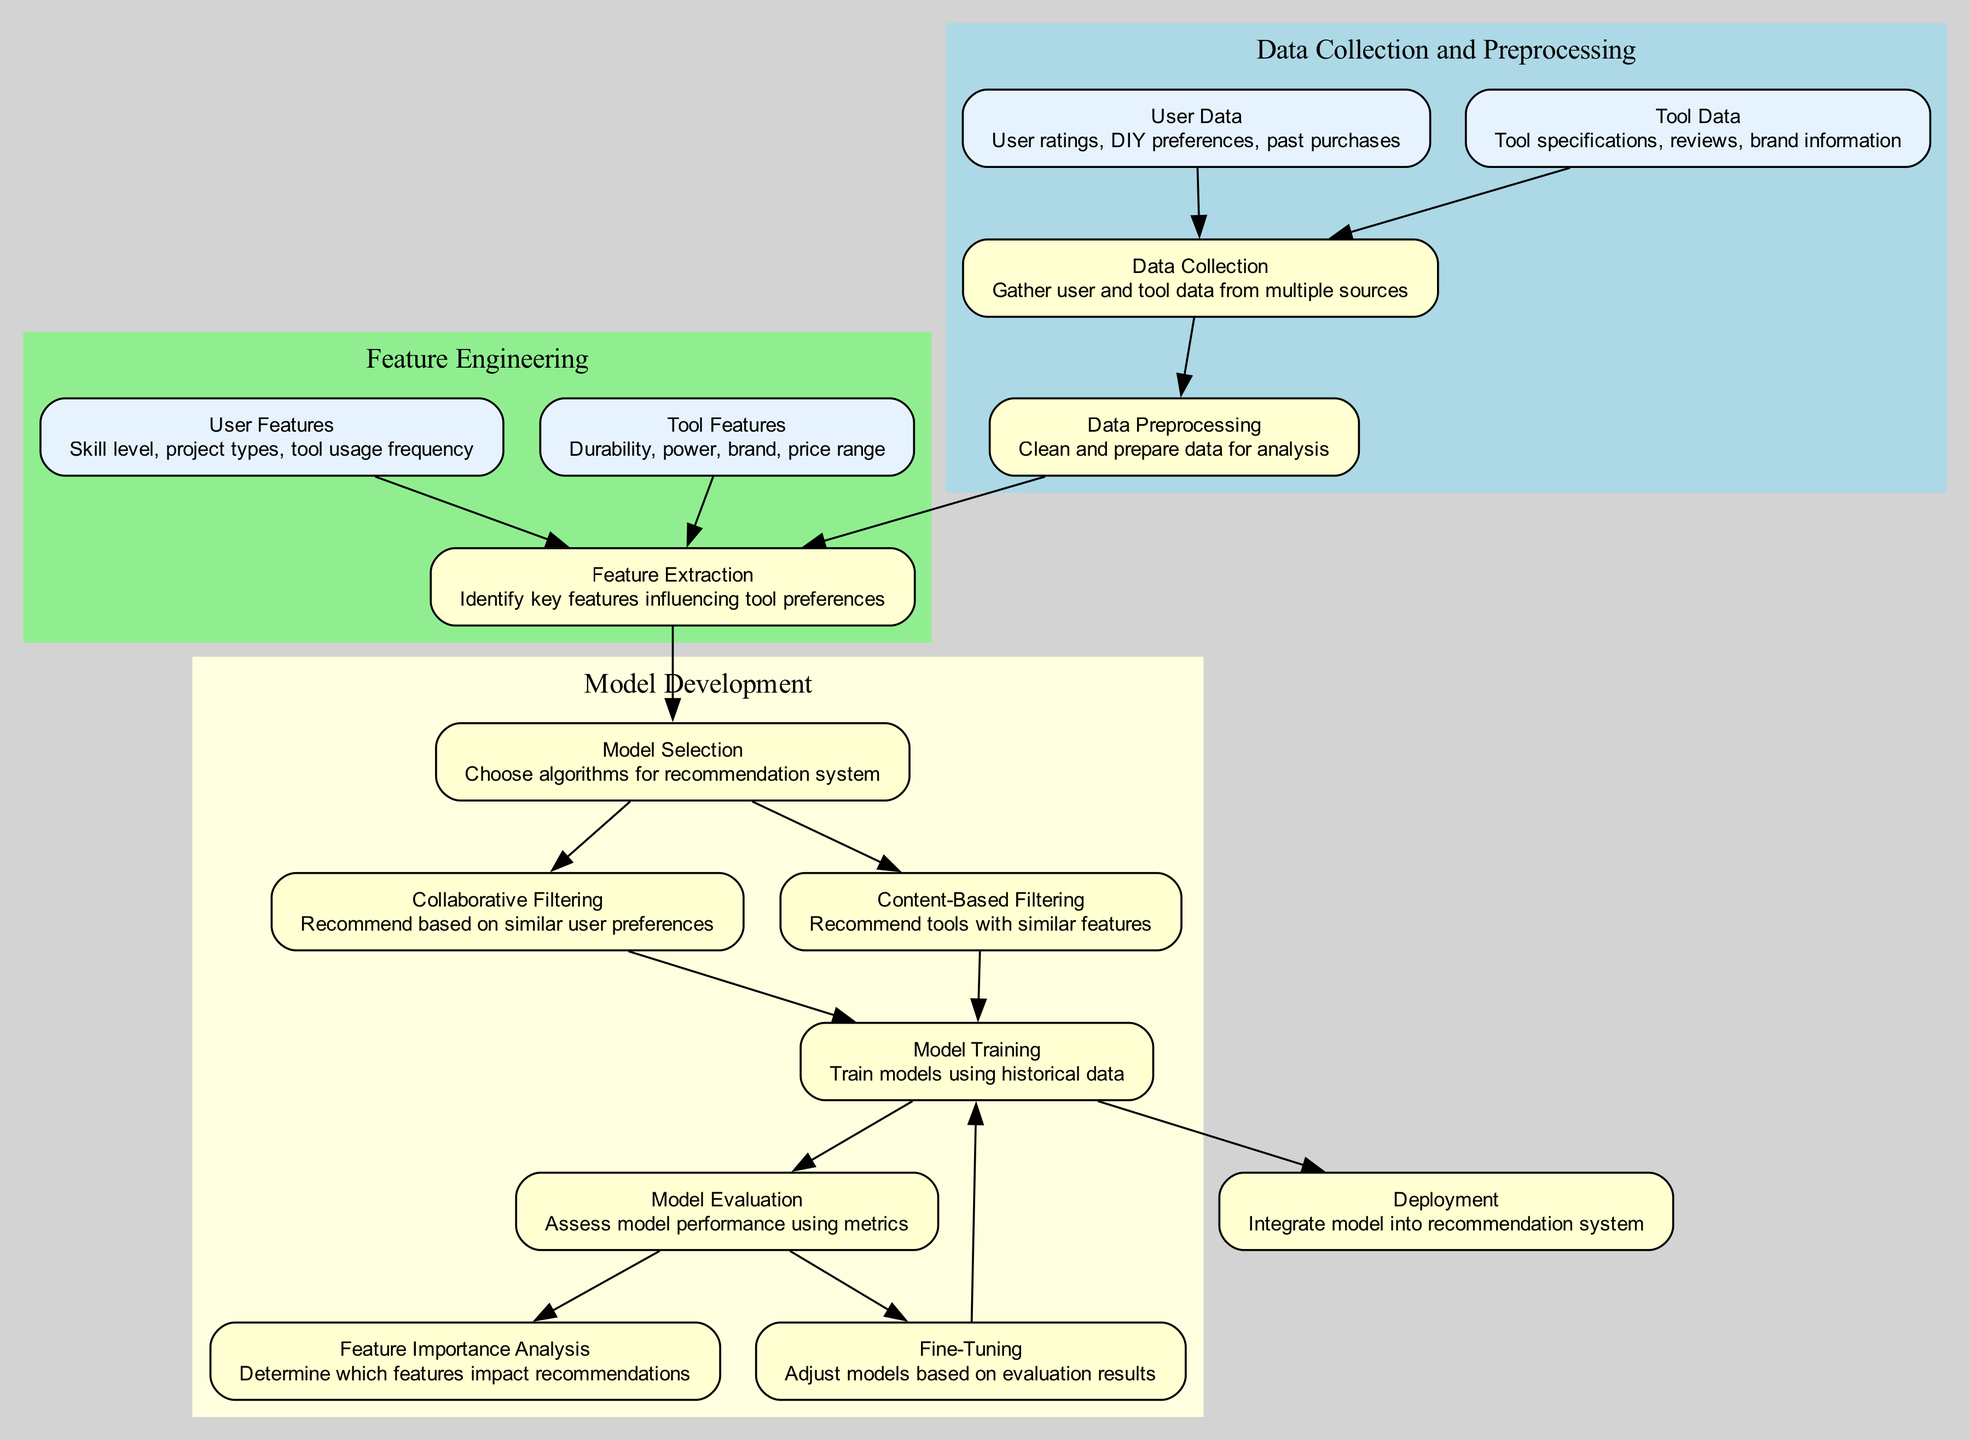What is the first step in the recommendation system process? The first step is 'Data Collection', as indicated by the node labeled '1'. This node is the starting point of the flow in the diagram, making it clear that gathering user and tool data is the initial action.
Answer: Data Collection How many nodes are present in the diagram? By counting each unique labeled node in the diagram, we can see that there are a total of 15 nodes. Each node represents a step or component in the recommendation system process.
Answer: 15 What two types of filtering are used in the model selection? The two types of filtering are 'Collaborative Filtering' and 'Content-Based Filtering'. These nodes are represented under the same category in the diagram, showcasing the methods of recommendation employed.
Answer: Collaborative Filtering, Content-Based Filtering Which feature influences tool preferences related to user skills? The feature that influences tool preferences related to user skills is 'Skill level', which falls under the 'User Features' node. This indicates a direct relationship between user skills and their tool preferences.
Answer: Skill level What is the last step before deployment in the process? The last step before deployment is 'Model Training', which is directly connected to the 'Deployment' node in the diagram, indicating the sequence of actions leading to integrating the model into the recommendation system.
Answer: Model Training How does the 'Feature Importance Analysis' relate to model evaluation? 'Feature Importance Analysis' follows 'Model Evaluation', as depicted in the diagram. This indicates that after assessing model performance using metrics, the next step is to determine which features significantly impact the recommendations.
Answer: Through assessment of model performance What steps require data from user features and tool features? The steps that require data from user features and tool features are 'Feature Extraction', where both types of features are necessary to identify key influencing parameters for tool recommendations. This is indicated by the arrows leading into this node.
Answer: Feature Extraction Which node indicates the adjustment of models based on evaluation results? The node indicating the adjustment of models based on evaluation results is 'Fine-Tuning'. This step is crucial in enhancing model performance, as shown in its position after 'Model Evaluation'.
Answer: Fine-Tuning 